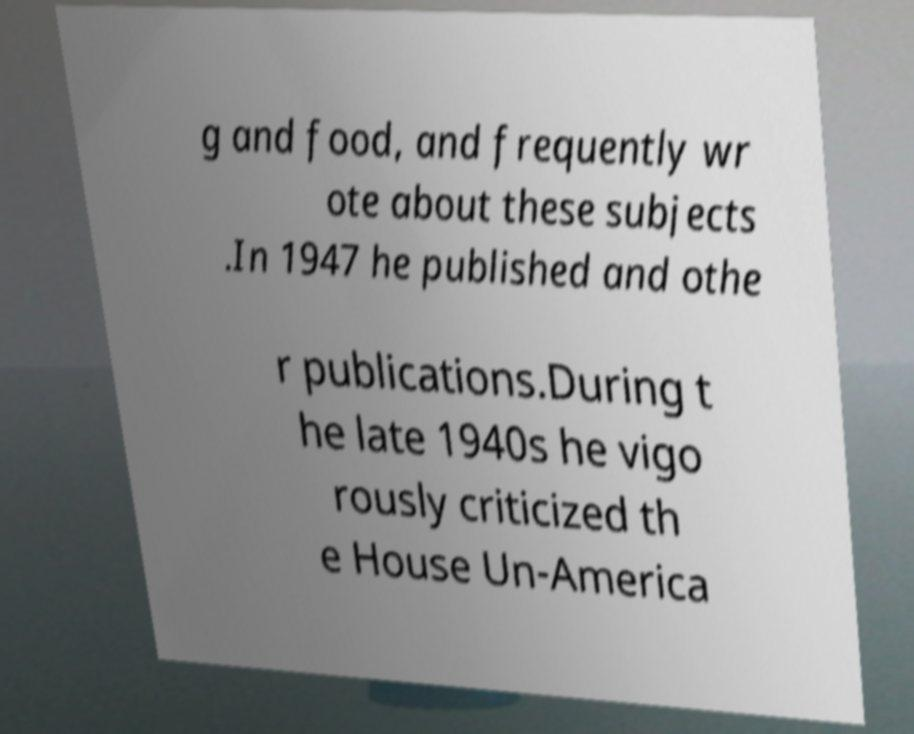There's text embedded in this image that I need extracted. Can you transcribe it verbatim? g and food, and frequently wr ote about these subjects .In 1947 he published and othe r publications.During t he late 1940s he vigo rously criticized th e House Un-America 